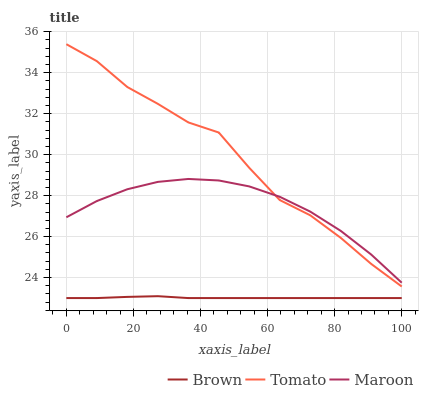Does Brown have the minimum area under the curve?
Answer yes or no. Yes. Does Tomato have the maximum area under the curve?
Answer yes or no. Yes. Does Maroon have the minimum area under the curve?
Answer yes or no. No. Does Maroon have the maximum area under the curve?
Answer yes or no. No. Is Brown the smoothest?
Answer yes or no. Yes. Is Tomato the roughest?
Answer yes or no. Yes. Is Maroon the smoothest?
Answer yes or no. No. Is Maroon the roughest?
Answer yes or no. No. Does Brown have the lowest value?
Answer yes or no. Yes. Does Maroon have the lowest value?
Answer yes or no. No. Does Tomato have the highest value?
Answer yes or no. Yes. Does Maroon have the highest value?
Answer yes or no. No. Is Brown less than Tomato?
Answer yes or no. Yes. Is Tomato greater than Brown?
Answer yes or no. Yes. Does Maroon intersect Tomato?
Answer yes or no. Yes. Is Maroon less than Tomato?
Answer yes or no. No. Is Maroon greater than Tomato?
Answer yes or no. No. Does Brown intersect Tomato?
Answer yes or no. No. 